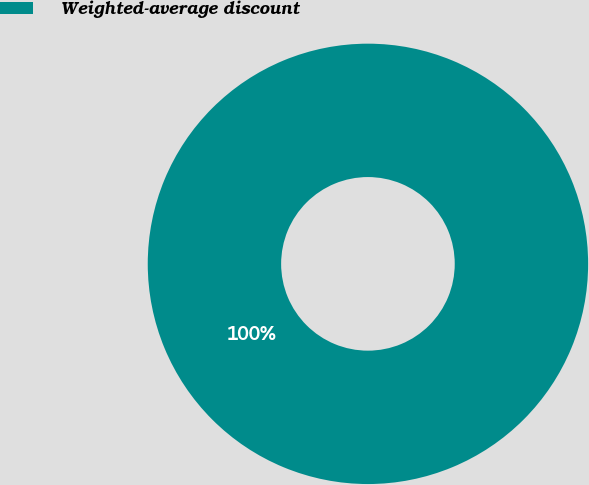Convert chart to OTSL. <chart><loc_0><loc_0><loc_500><loc_500><pie_chart><fcel>Weighted-average discount<nl><fcel>100.0%<nl></chart> 